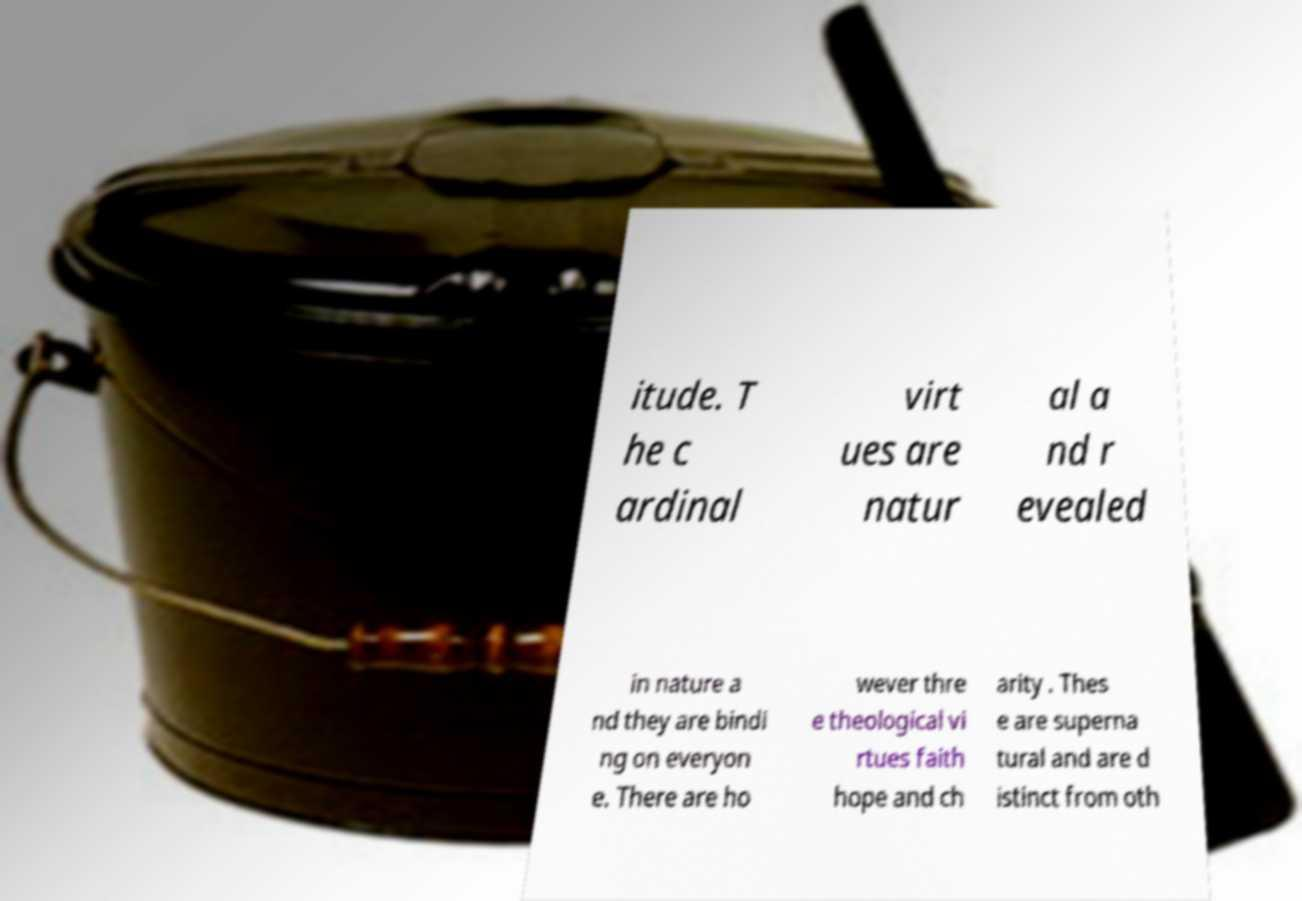For documentation purposes, I need the text within this image transcribed. Could you provide that? itude. T he c ardinal virt ues are natur al a nd r evealed in nature a nd they are bindi ng on everyon e. There are ho wever thre e theological vi rtues faith hope and ch arity . Thes e are superna tural and are d istinct from oth 